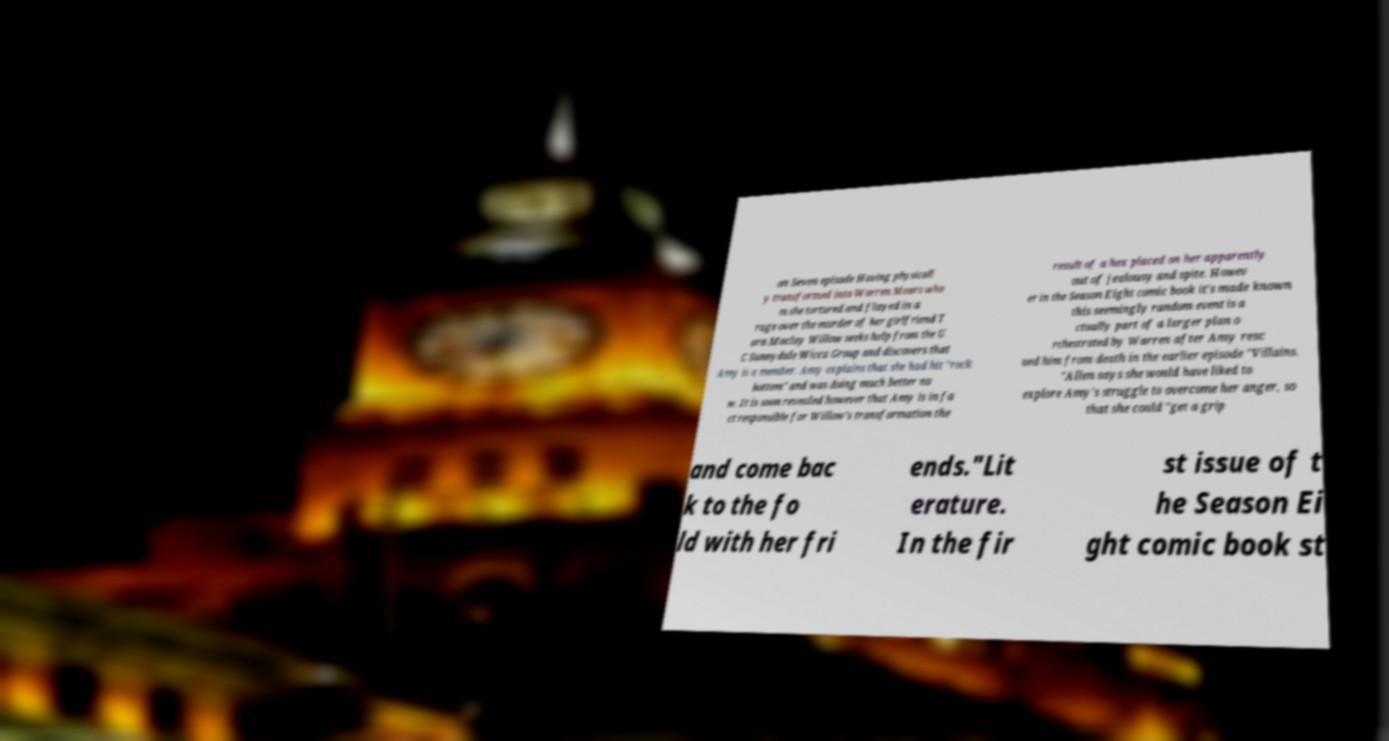Please identify and transcribe the text found in this image. on Seven episode Having physicall y transformed into Warren Mears who m she tortured and flayed in a rage over the murder of her girlfriend T ara Maclay Willow seeks help from the U C Sunnydale Wicca Group and discovers that Amy is a member. Amy explains that she had hit "rock bottom" and was doing much better no w. It is soon revealed however that Amy is in fa ct responsible for Willow's transformation the result of a hex placed on her apparently out of jealousy and spite. Howev er in the Season Eight comic book it's made known this seemingly random event is a ctually part of a larger plan o rchestrated by Warren after Amy resc ued him from death in the earlier episode "Villains. "Allen says she would have liked to explore Amy's struggle to overcome her anger, so that she could "get a grip and come bac k to the fo ld with her fri ends."Lit erature. In the fir st issue of t he Season Ei ght comic book st 